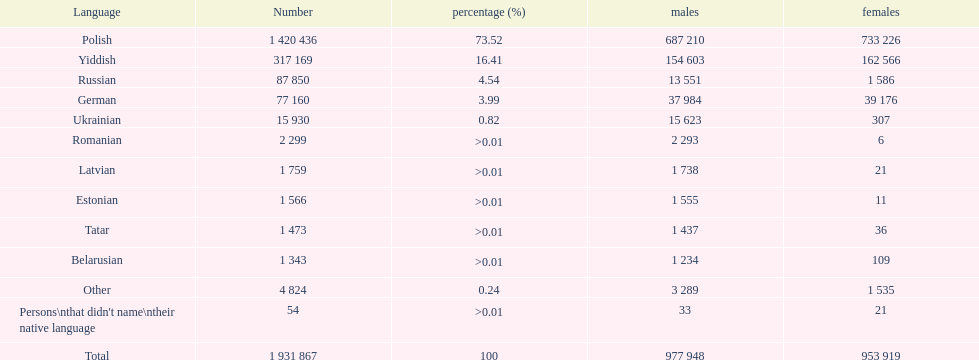What was the leading language that had a percentage exceeding Romanian. 